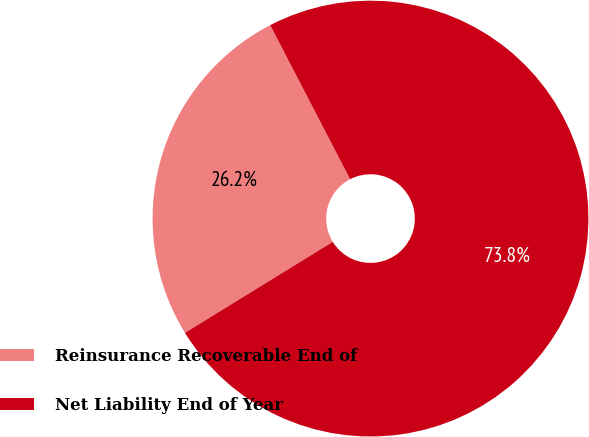Convert chart. <chart><loc_0><loc_0><loc_500><loc_500><pie_chart><fcel>Reinsurance Recoverable End of<fcel>Net Liability End of Year<nl><fcel>26.17%<fcel>73.83%<nl></chart> 